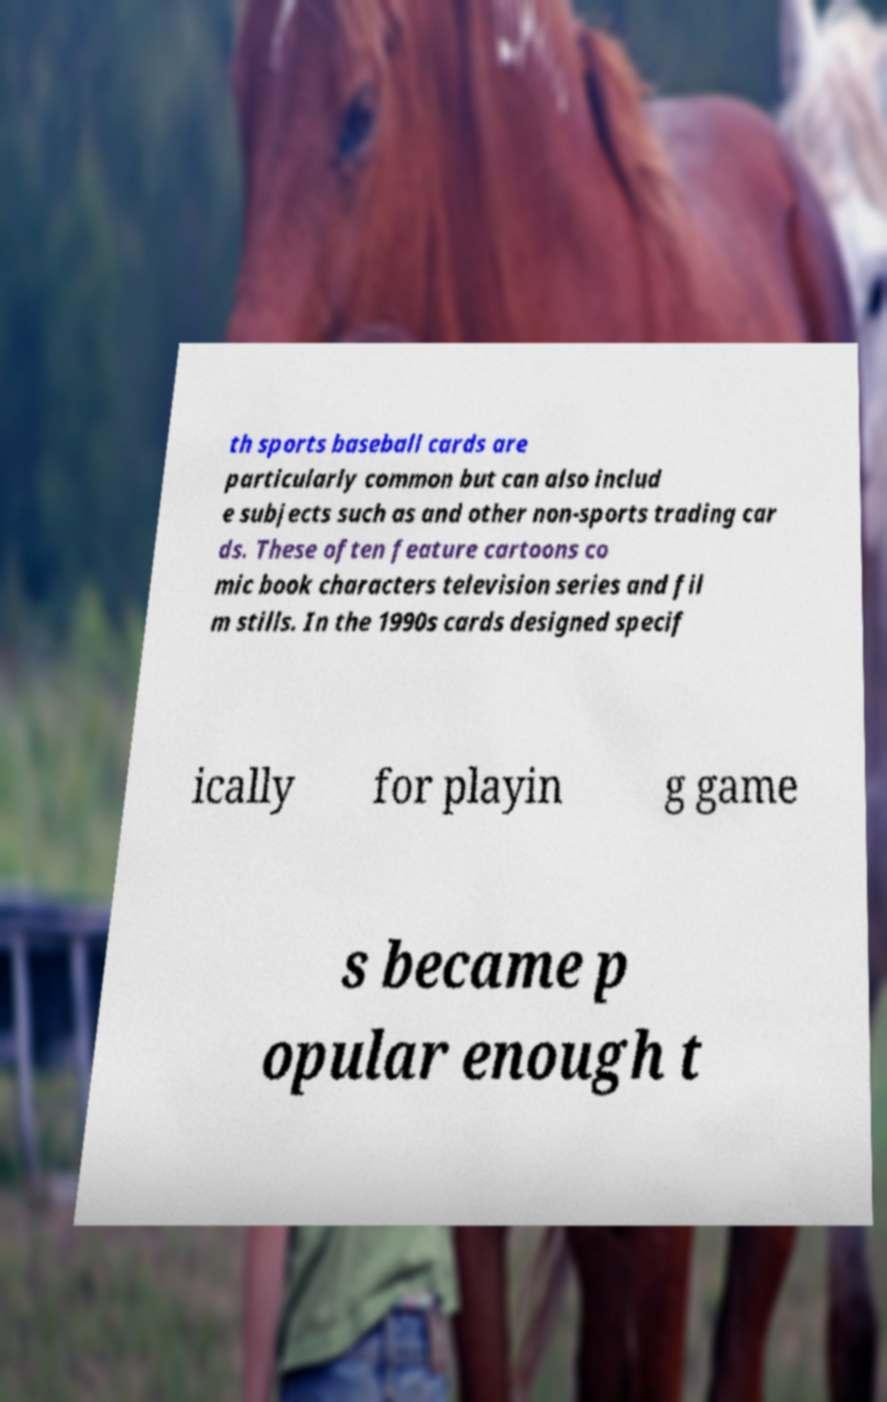Could you assist in decoding the text presented in this image and type it out clearly? th sports baseball cards are particularly common but can also includ e subjects such as and other non-sports trading car ds. These often feature cartoons co mic book characters television series and fil m stills. In the 1990s cards designed specif ically for playin g game s became p opular enough t 